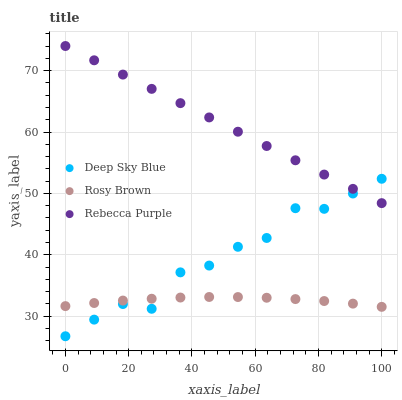Does Rosy Brown have the minimum area under the curve?
Answer yes or no. Yes. Does Rebecca Purple have the maximum area under the curve?
Answer yes or no. Yes. Does Deep Sky Blue have the minimum area under the curve?
Answer yes or no. No. Does Deep Sky Blue have the maximum area under the curve?
Answer yes or no. No. Is Rebecca Purple the smoothest?
Answer yes or no. Yes. Is Deep Sky Blue the roughest?
Answer yes or no. Yes. Is Deep Sky Blue the smoothest?
Answer yes or no. No. Is Rebecca Purple the roughest?
Answer yes or no. No. Does Deep Sky Blue have the lowest value?
Answer yes or no. Yes. Does Rebecca Purple have the lowest value?
Answer yes or no. No. Does Rebecca Purple have the highest value?
Answer yes or no. Yes. Does Deep Sky Blue have the highest value?
Answer yes or no. No. Is Rosy Brown less than Rebecca Purple?
Answer yes or no. Yes. Is Rebecca Purple greater than Rosy Brown?
Answer yes or no. Yes. Does Deep Sky Blue intersect Rosy Brown?
Answer yes or no. Yes. Is Deep Sky Blue less than Rosy Brown?
Answer yes or no. No. Is Deep Sky Blue greater than Rosy Brown?
Answer yes or no. No. Does Rosy Brown intersect Rebecca Purple?
Answer yes or no. No. 